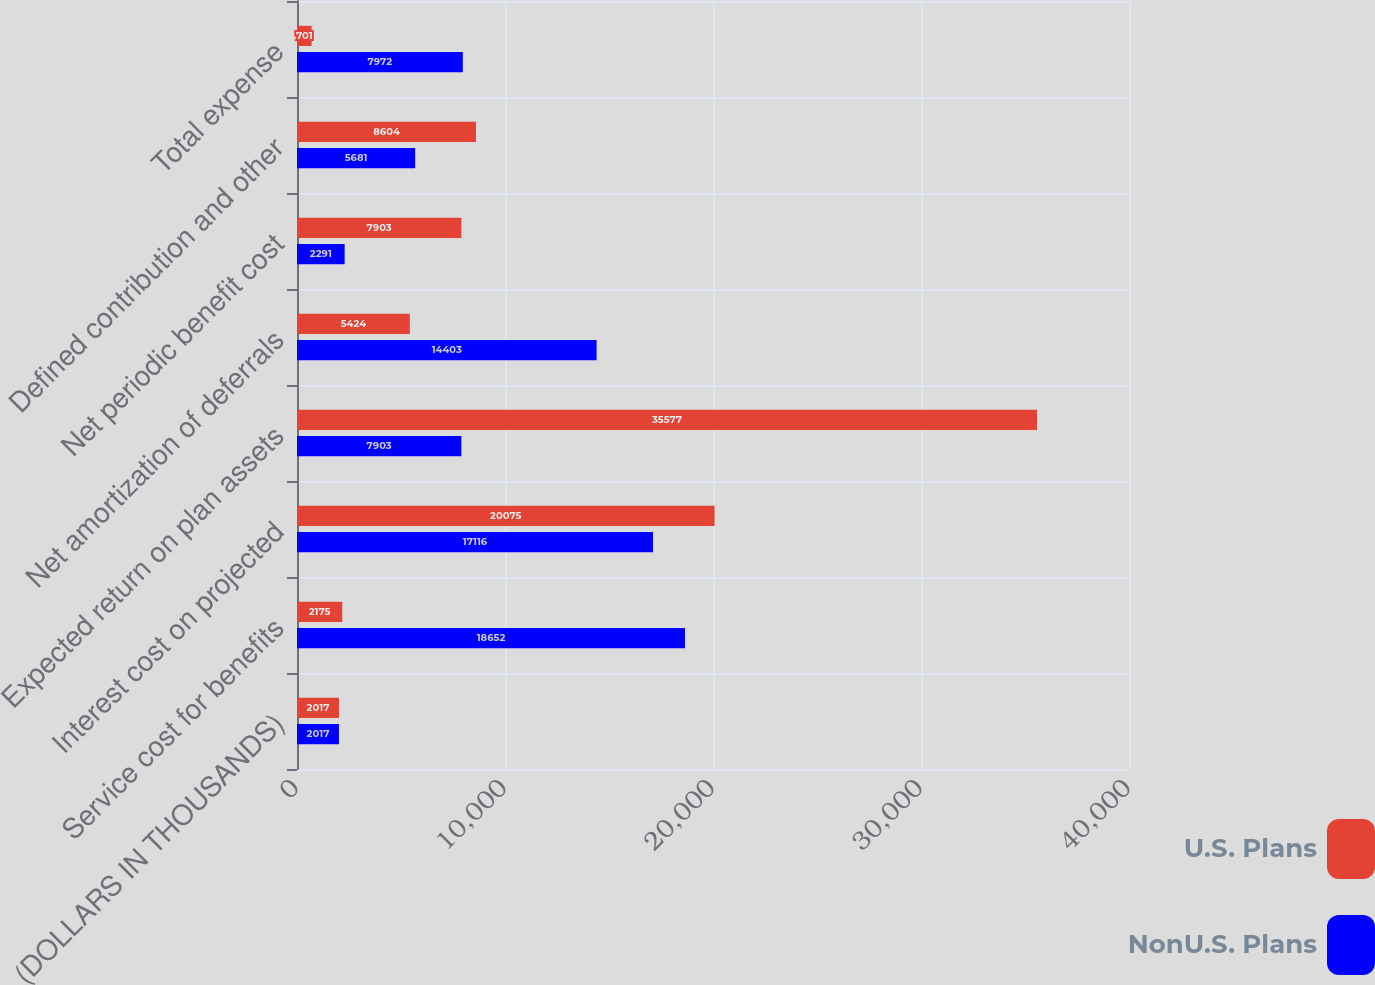Convert chart to OTSL. <chart><loc_0><loc_0><loc_500><loc_500><stacked_bar_chart><ecel><fcel>(DOLLARS IN THOUSANDS)<fcel>Service cost for benefits<fcel>Interest cost on projected<fcel>Expected return on plan assets<fcel>Net amortization of deferrals<fcel>Net periodic benefit cost<fcel>Defined contribution and other<fcel>Total expense<nl><fcel>U.S. Plans<fcel>2017<fcel>2175<fcel>20075<fcel>35577<fcel>5424<fcel>7903<fcel>8604<fcel>701<nl><fcel>NonU.S. Plans<fcel>2017<fcel>18652<fcel>17116<fcel>7903<fcel>14403<fcel>2291<fcel>5681<fcel>7972<nl></chart> 